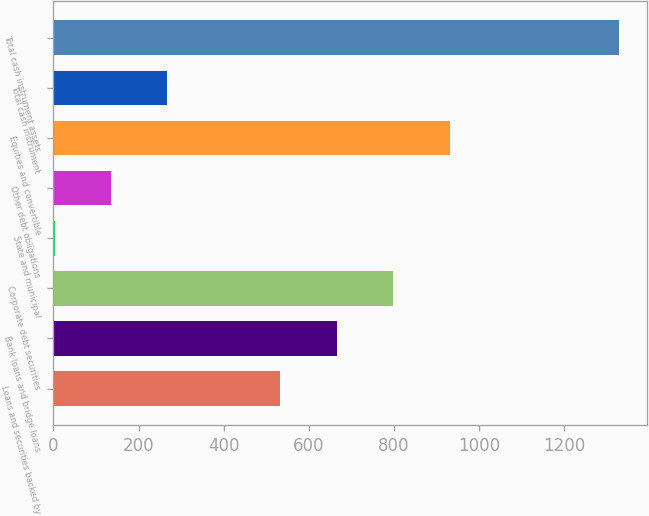Convert chart to OTSL. <chart><loc_0><loc_0><loc_500><loc_500><bar_chart><fcel>Loans and securities backed by<fcel>Bank loans and bridge loans<fcel>Corporate debt securities<fcel>State and municipal<fcel>Other debt obligations<fcel>Equities and convertible<fcel>Total cash instrument<fcel>Total cash instrument assets<nl><fcel>533<fcel>665.5<fcel>798<fcel>3<fcel>135.5<fcel>930.5<fcel>268<fcel>1328<nl></chart> 